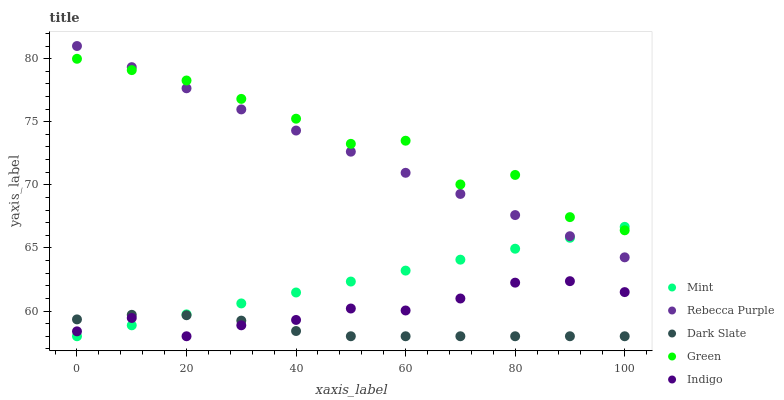Does Dark Slate have the minimum area under the curve?
Answer yes or no. Yes. Does Green have the maximum area under the curve?
Answer yes or no. Yes. Does Mint have the minimum area under the curve?
Answer yes or no. No. Does Mint have the maximum area under the curve?
Answer yes or no. No. Is Mint the smoothest?
Answer yes or no. Yes. Is Green the roughest?
Answer yes or no. Yes. Is Green the smoothest?
Answer yes or no. No. Is Mint the roughest?
Answer yes or no. No. Does Dark Slate have the lowest value?
Answer yes or no. Yes. Does Green have the lowest value?
Answer yes or no. No. Does Rebecca Purple have the highest value?
Answer yes or no. Yes. Does Green have the highest value?
Answer yes or no. No. Is Indigo less than Green?
Answer yes or no. Yes. Is Rebecca Purple greater than Dark Slate?
Answer yes or no. Yes. Does Indigo intersect Dark Slate?
Answer yes or no. Yes. Is Indigo less than Dark Slate?
Answer yes or no. No. Is Indigo greater than Dark Slate?
Answer yes or no. No. Does Indigo intersect Green?
Answer yes or no. No. 